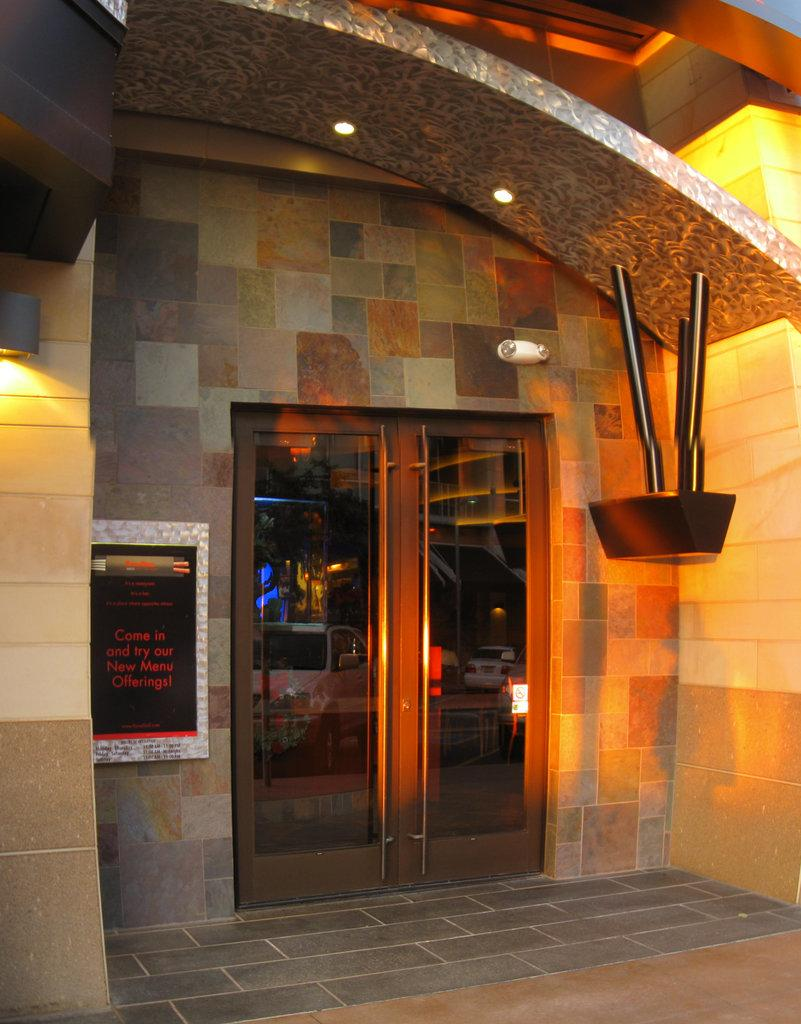What type of structure is visible in the image? There is a building in the image. What feature of the building is mentioned in the facts? The building has a glass door. Can the glass door be accessed? Yes, the glass door can be accessed. What security feature is present on the building? There is a CC camera on top of the door. How does the building learn to stretch in the image? Buildings do not have the ability to learn or stretch; they are inanimate structures. 